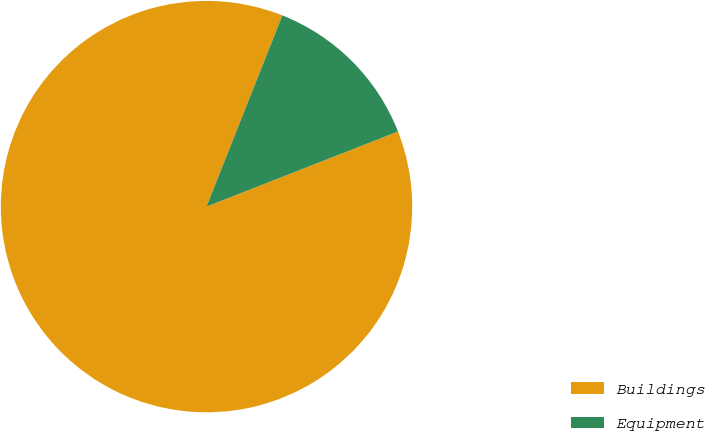<chart> <loc_0><loc_0><loc_500><loc_500><pie_chart><fcel>Buildings<fcel>Equipment<nl><fcel>86.96%<fcel>13.04%<nl></chart> 